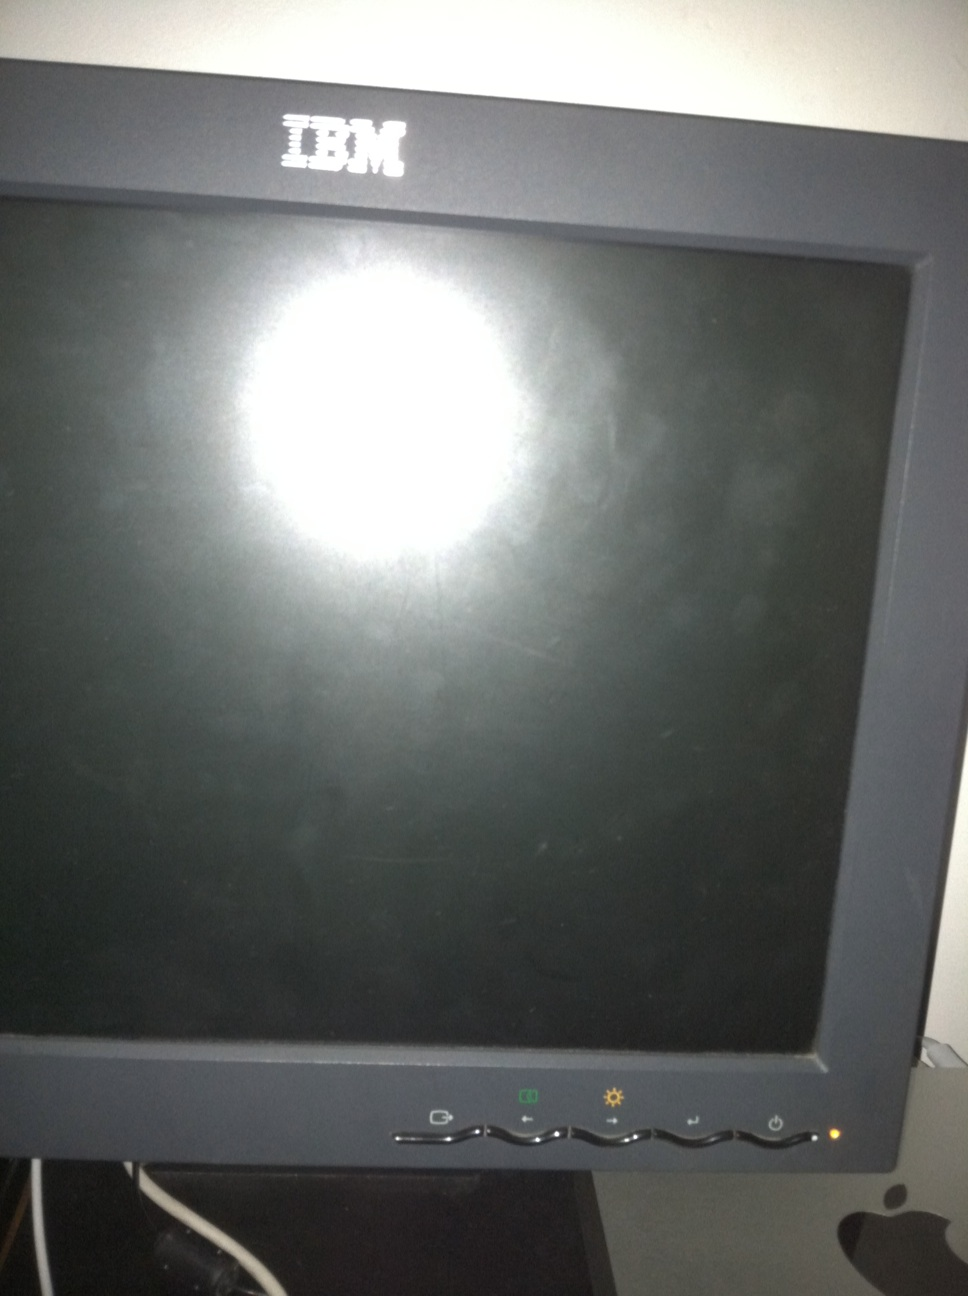Is the screen on now? No, the screen is off. We can tell because there is no visible content on the display, just a reflection from surrounding lighting. 